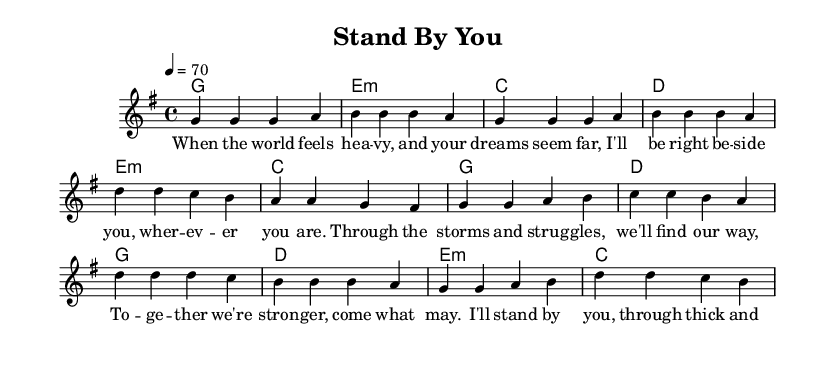What is the key signature of this music? The key signature is G major, indicated by one sharp in the music notation.
Answer: G major What is the time signature of the piece? The time signature is 4/4, shown at the beginning of the music, indicating four beats per measure.
Answer: 4/4 What is the tempo marking for this piece? The tempo marking is 4 = 70, which means that there are 70 quarter note beats per minute.
Answer: 70 How many measures are in the verse section of the song? The verse consists of four measures, as indicated by the groupings in the melody section.
Answer: 4 What type of chord is the first chord in the harmonies? The first chord is a G major chord, indicated by the letter 'g' at the start of the harmonies section.
Answer: G What is the last lyric phrase in the verse? The last lyric phrase in the verse reads "I'll help you be -- gin," which is clearly marked at the end of the verse lyrics.
Answer: "I'll help you be -- gin." How does the pre-chorus transition to the chorus musically? The pre-chorus transitions to the chorus by sequencing the chords that lead into a more uplifting progression, specifically moving from the chord progression ending in 'd' to starting the chorus with 'g.'
Answer: Through chord progression 